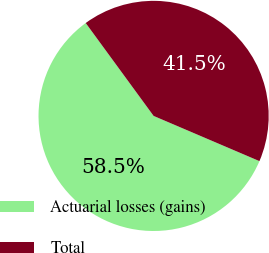Convert chart. <chart><loc_0><loc_0><loc_500><loc_500><pie_chart><fcel>Actuarial losses (gains)<fcel>Total<nl><fcel>58.53%<fcel>41.47%<nl></chart> 